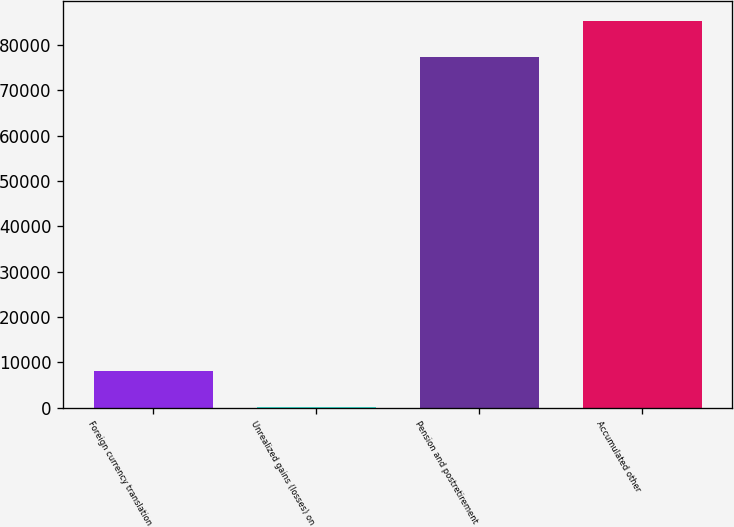Convert chart to OTSL. <chart><loc_0><loc_0><loc_500><loc_500><bar_chart><fcel>Foreign currency translation<fcel>Unrealized gains (losses) on<fcel>Pension and postretirement<fcel>Accumulated other<nl><fcel>8150.4<fcel>110<fcel>77318<fcel>85358.4<nl></chart> 